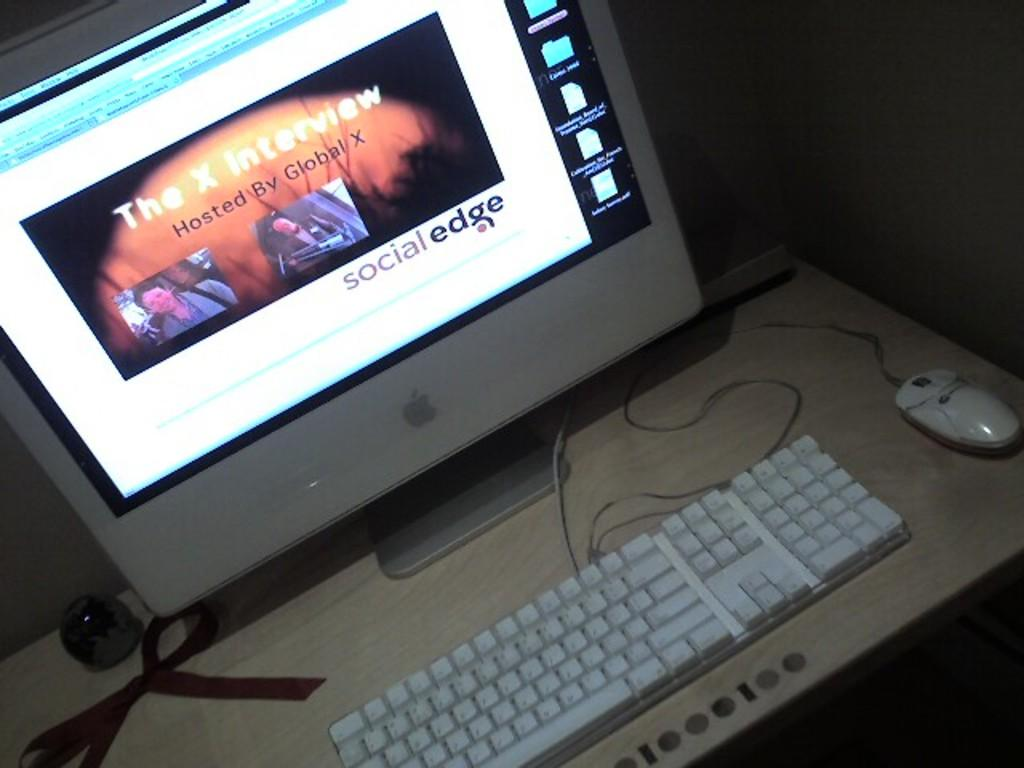<image>
Render a clear and concise summary of the photo. An Apple computer where the screen says The X Interview Hosted by Global X on the screen 